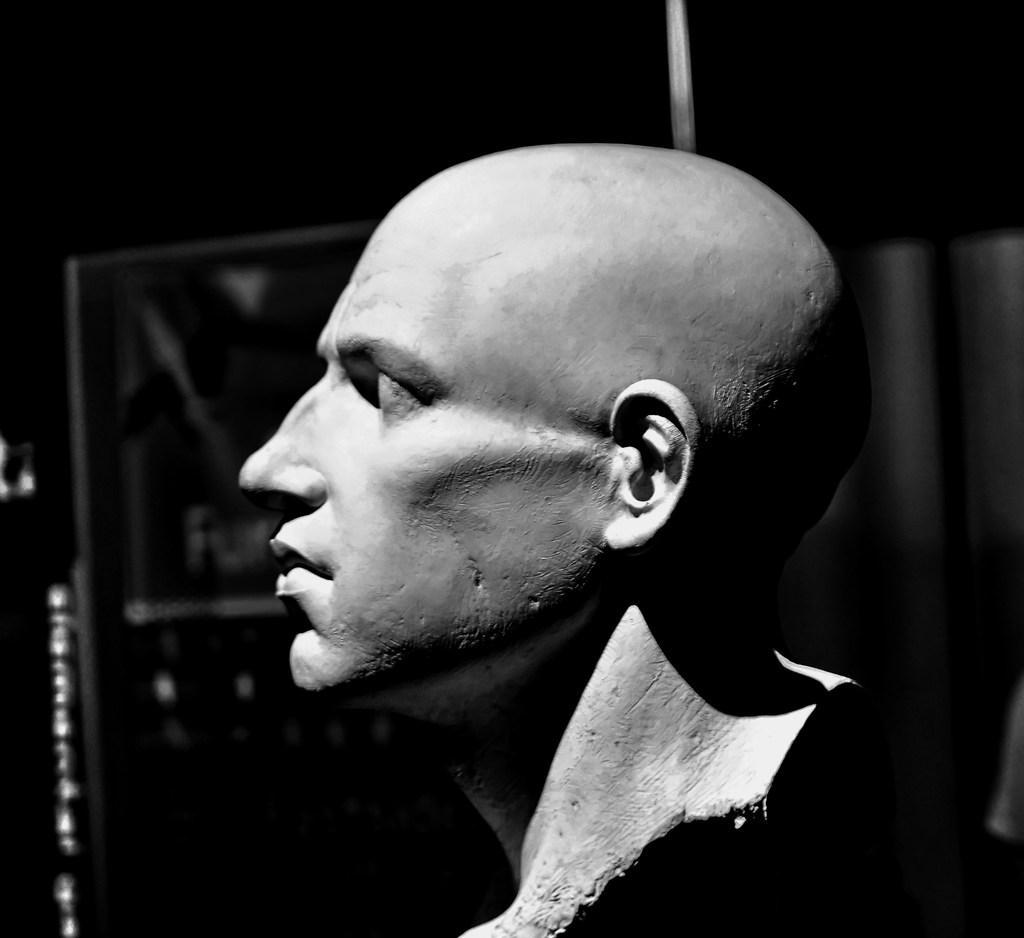Could you give a brief overview of what you see in this image? This is a black and white image where we can see a statue of a human. It seems like a door in the background. 